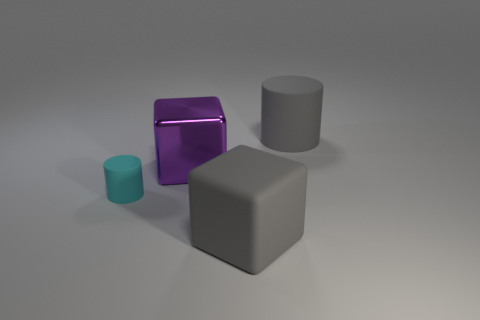Add 1 large purple rubber blocks. How many objects exist? 5 Subtract all large purple metal cubes. Subtract all purple metallic cubes. How many objects are left? 2 Add 3 cyan objects. How many cyan objects are left? 4 Add 3 shiny cubes. How many shiny cubes exist? 4 Subtract 0 blue cubes. How many objects are left? 4 